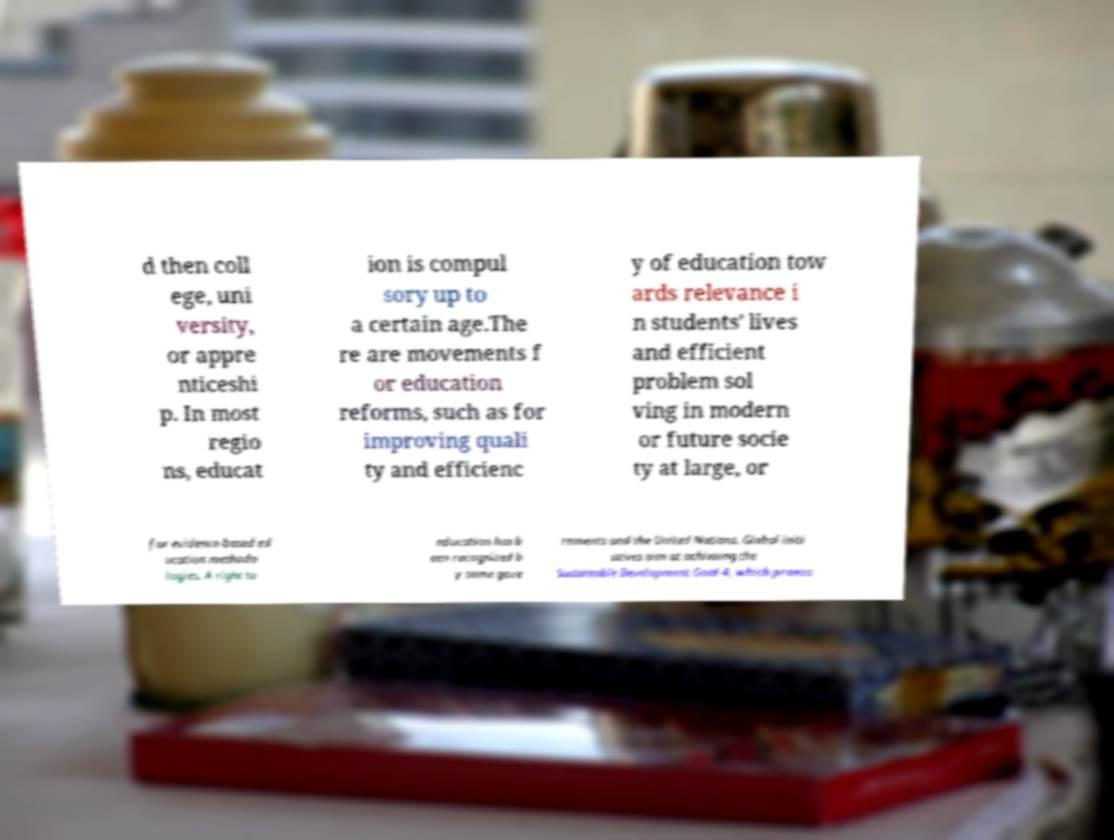Can you read and provide the text displayed in the image?This photo seems to have some interesting text. Can you extract and type it out for me? d then coll ege, uni versity, or appre nticeshi p. In most regio ns, educat ion is compul sory up to a certain age.The re are movements f or education reforms, such as for improving quali ty and efficienc y of education tow ards relevance i n students' lives and efficient problem sol ving in modern or future socie ty at large, or for evidence-based ed ucation methodo logies. A right to education has b een recognized b y some gove rnments and the United Nations. Global initi atives aim at achieving the Sustainable Development Goal 4, which promo 